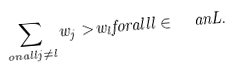<formula> <loc_0><loc_0><loc_500><loc_500>\sum _ { o n a l l j \ne l } w _ { j } > w _ { l } f o r a l l l \in \ a n { L } .</formula> 